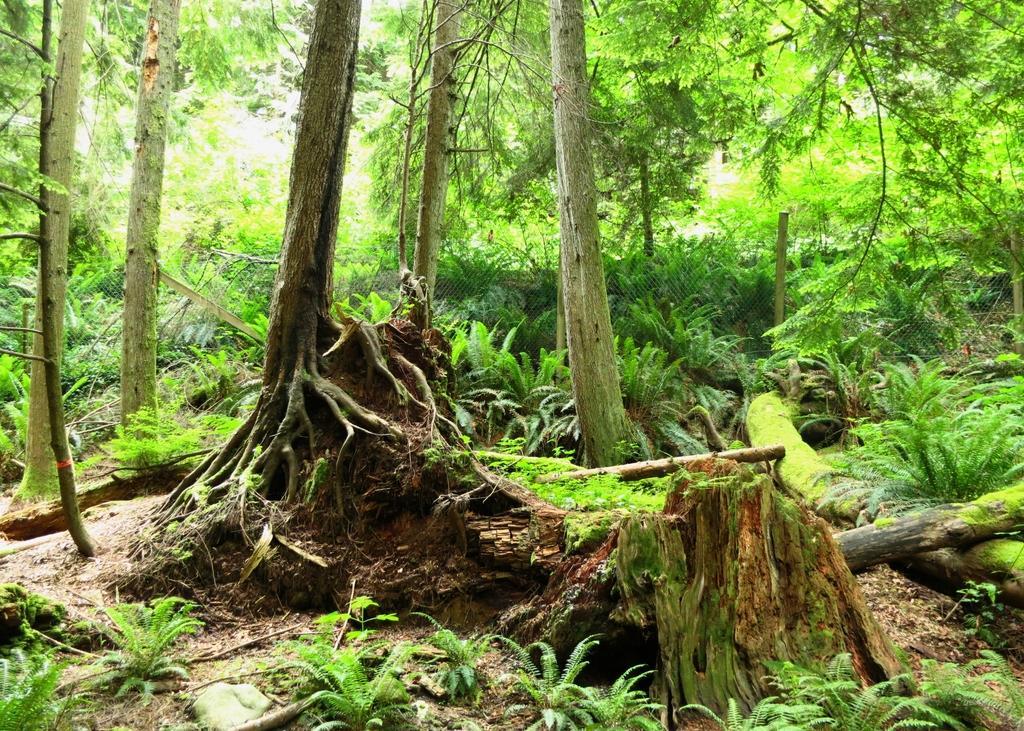Can you describe this image briefly? In this image, we can see trees and plants and there is a mesh. 